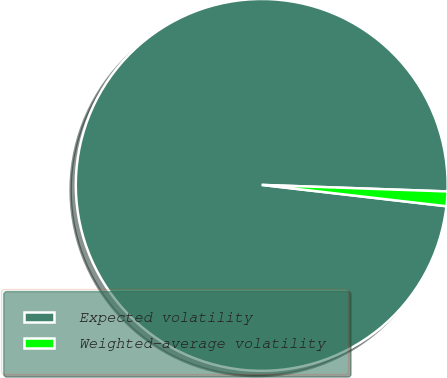Convert chart. <chart><loc_0><loc_0><loc_500><loc_500><pie_chart><fcel>Expected volatility<fcel>Weighted-average volatility<nl><fcel>98.73%<fcel>1.27%<nl></chart> 